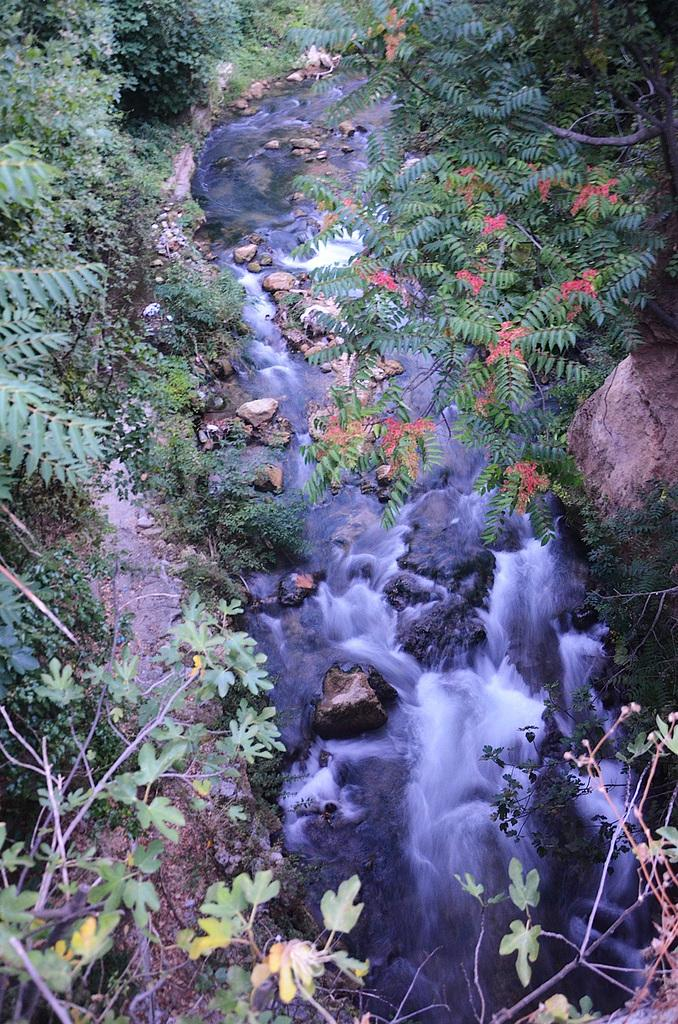What is the primary element visible in the image? There is water in the image. What other objects can be seen in the image? There are stones and trees visible in the image. How many bees can be seen flying around the trees in the image? There are no bees visible in the image; only water, stones, and trees are present. What type of camera is used to capture the image? The type of camera used to capture the image is not mentioned in the provided facts. 